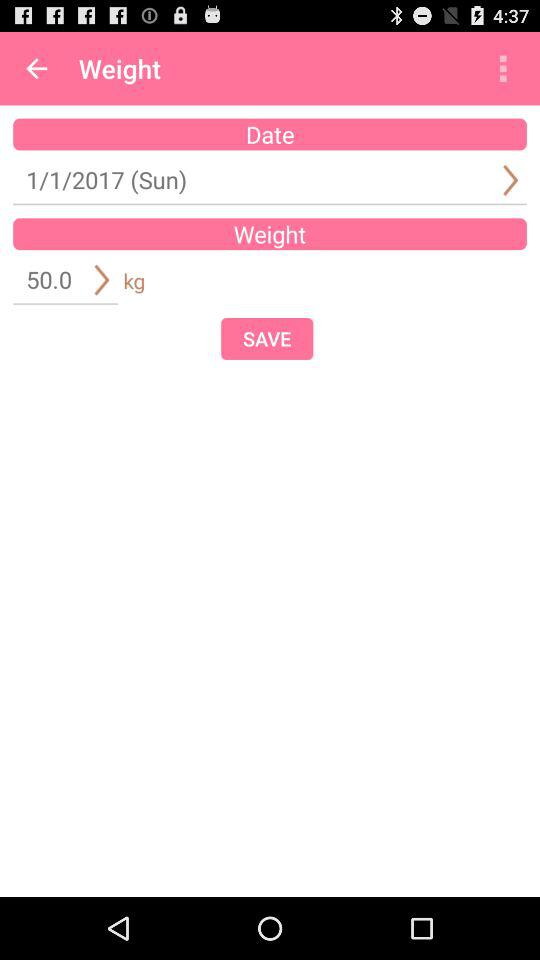What is the mentioned weight? The weight is 50.0 kg. 